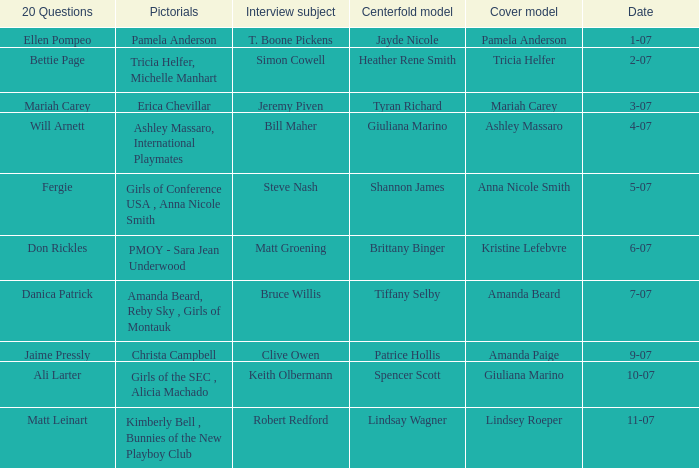Who answered the 20 questions on 10-07? Ali Larter. 